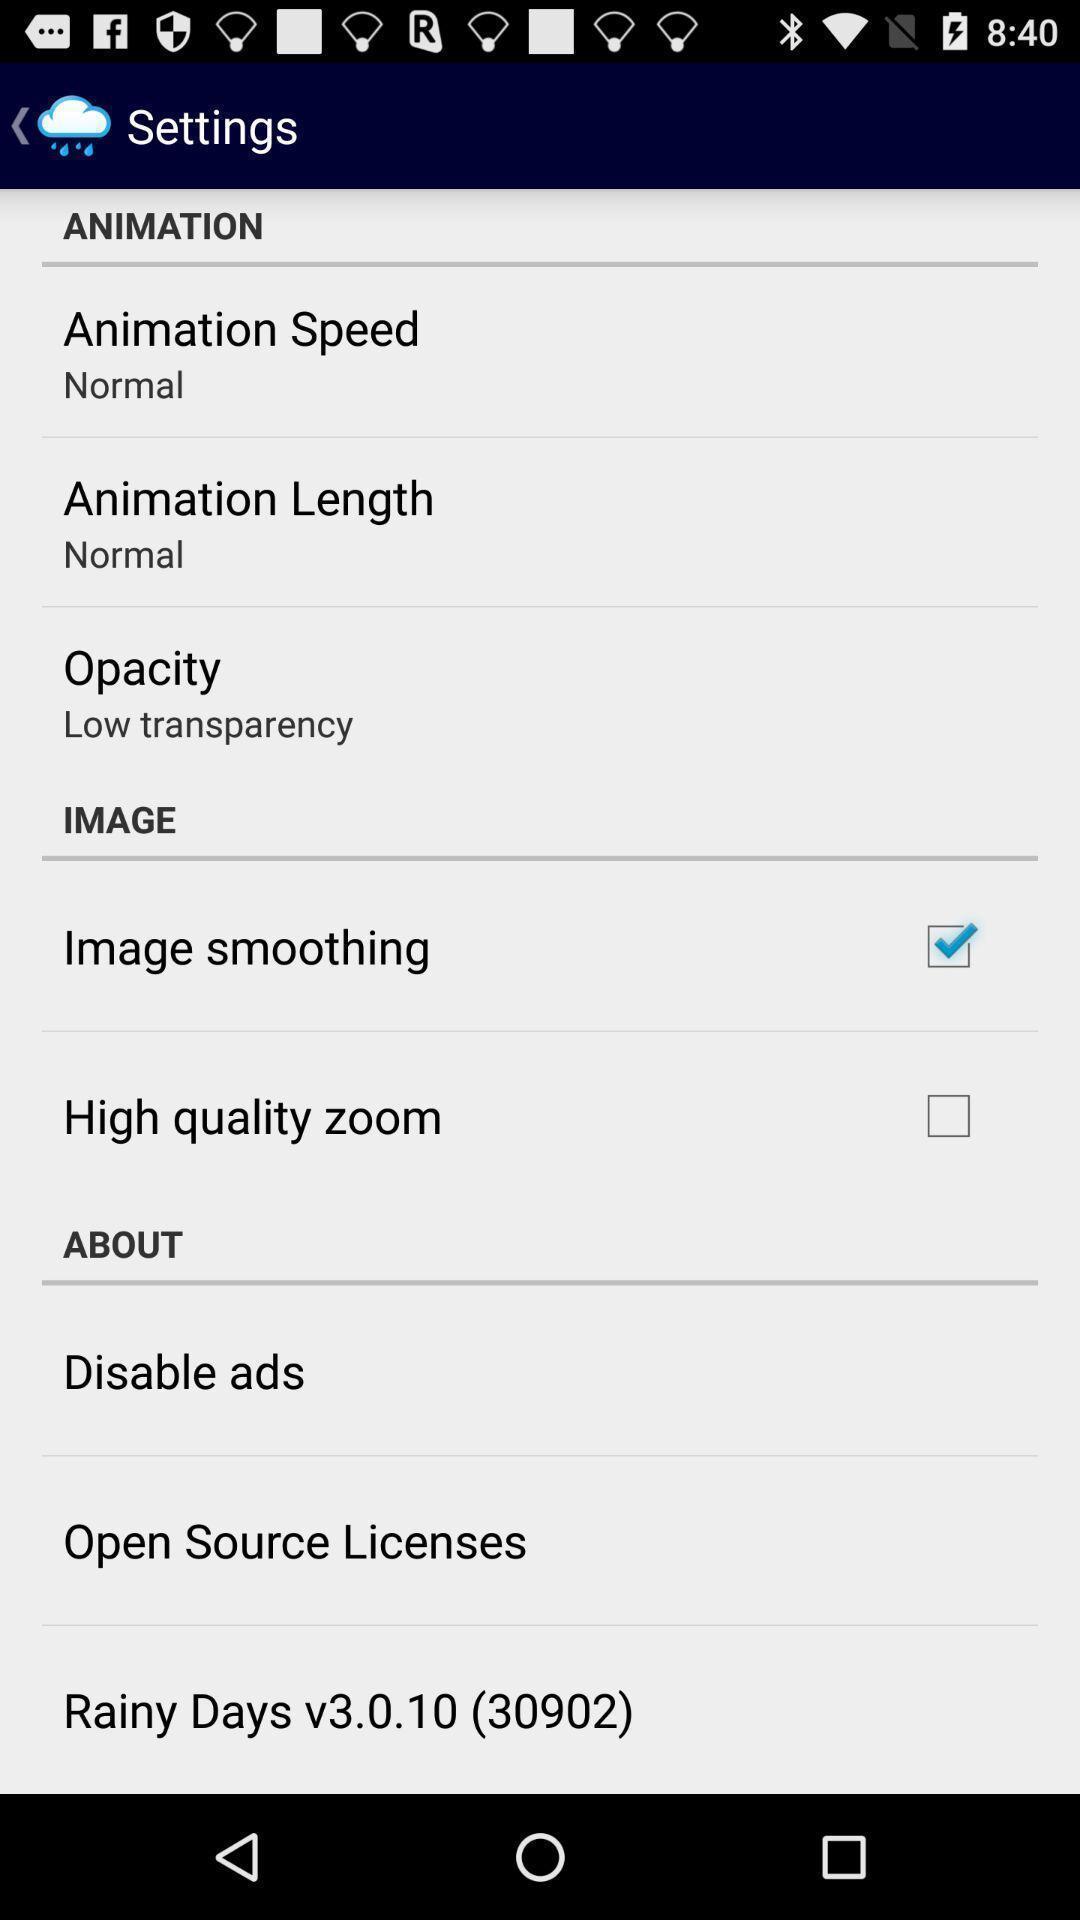Summarize the information in this screenshot. Screen showing settings page. 